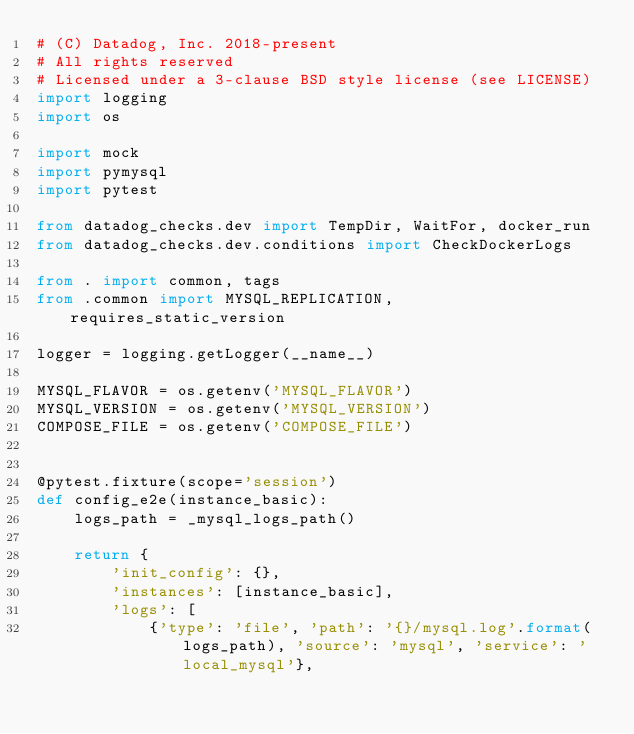Convert code to text. <code><loc_0><loc_0><loc_500><loc_500><_Python_># (C) Datadog, Inc. 2018-present
# All rights reserved
# Licensed under a 3-clause BSD style license (see LICENSE)
import logging
import os

import mock
import pymysql
import pytest

from datadog_checks.dev import TempDir, WaitFor, docker_run
from datadog_checks.dev.conditions import CheckDockerLogs

from . import common, tags
from .common import MYSQL_REPLICATION, requires_static_version

logger = logging.getLogger(__name__)

MYSQL_FLAVOR = os.getenv('MYSQL_FLAVOR')
MYSQL_VERSION = os.getenv('MYSQL_VERSION')
COMPOSE_FILE = os.getenv('COMPOSE_FILE')


@pytest.fixture(scope='session')
def config_e2e(instance_basic):
    logs_path = _mysql_logs_path()

    return {
        'init_config': {},
        'instances': [instance_basic],
        'logs': [
            {'type': 'file', 'path': '{}/mysql.log'.format(logs_path), 'source': 'mysql', 'service': 'local_mysql'},</code> 